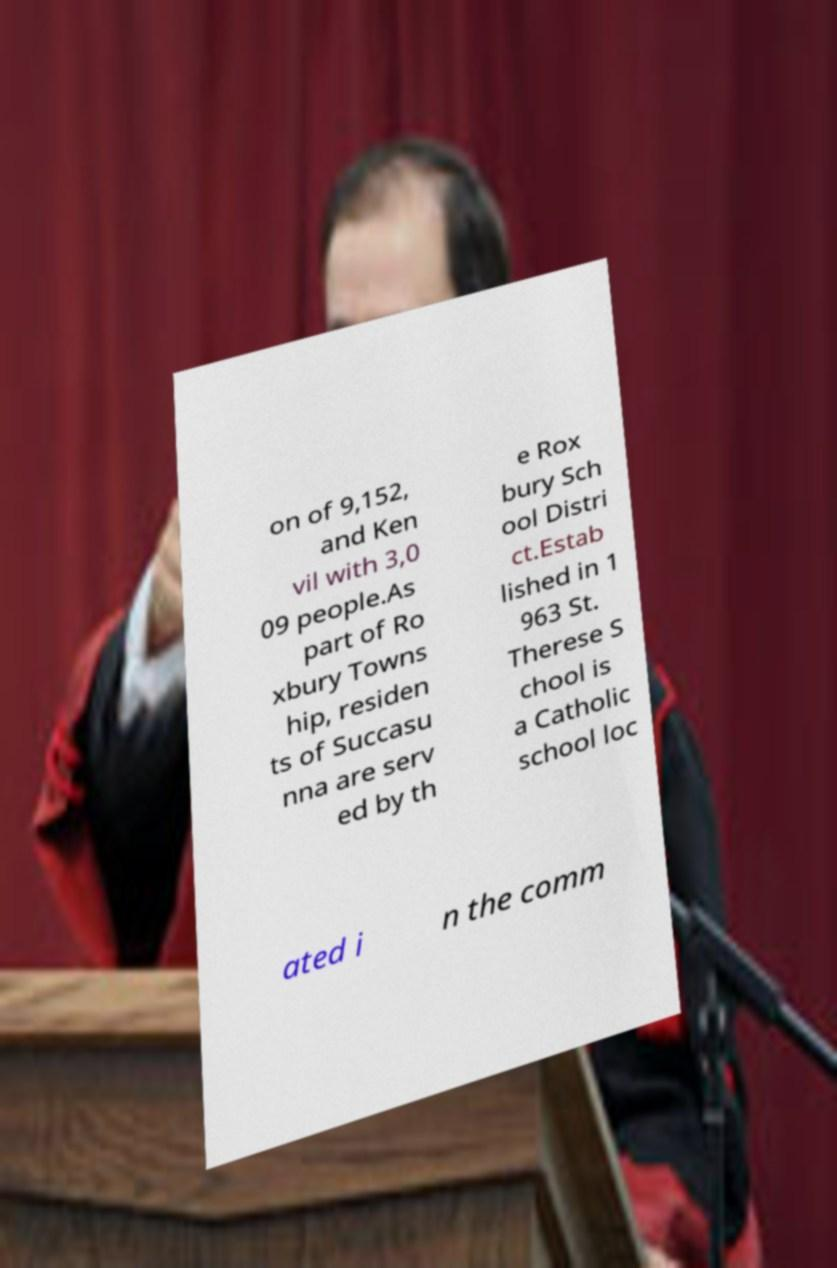Please read and relay the text visible in this image. What does it say? on of 9,152, and Ken vil with 3,0 09 people.As part of Ro xbury Towns hip, residen ts of Succasu nna are serv ed by th e Rox bury Sch ool Distri ct.Estab lished in 1 963 St. Therese S chool is a Catholic school loc ated i n the comm 